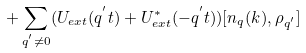<formula> <loc_0><loc_0><loc_500><loc_500>+ \sum _ { { q } ^ { ^ { \prime } } \neq 0 } ( U _ { e x t } ( { q } ^ { ^ { \prime } } t ) + U ^ { * } _ { e x t } ( - { q } ^ { ^ { \prime } } t ) ) [ n _ { q } ( { k } ) , \rho _ { { q } ^ { ^ { \prime } } } ]</formula> 